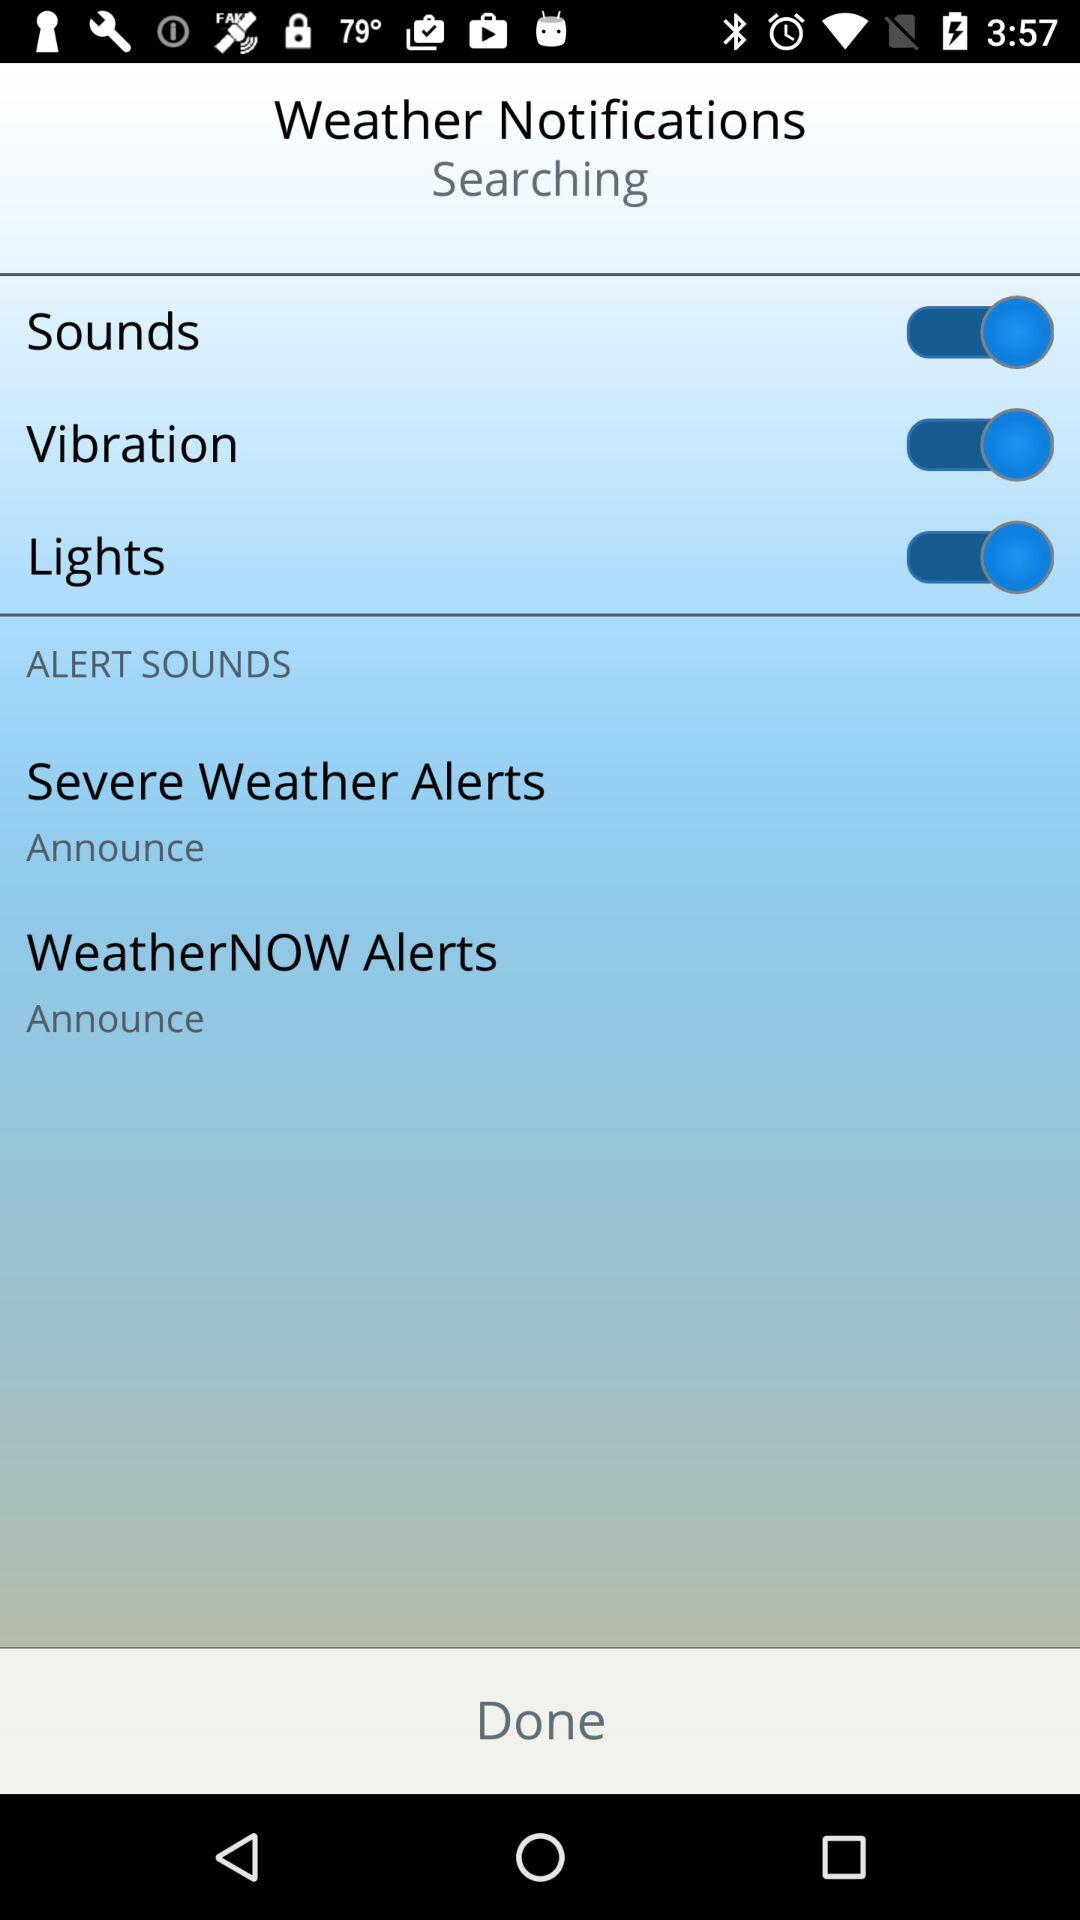How many alerts are there that have an announce option?
Answer the question using a single word or phrase. 2 